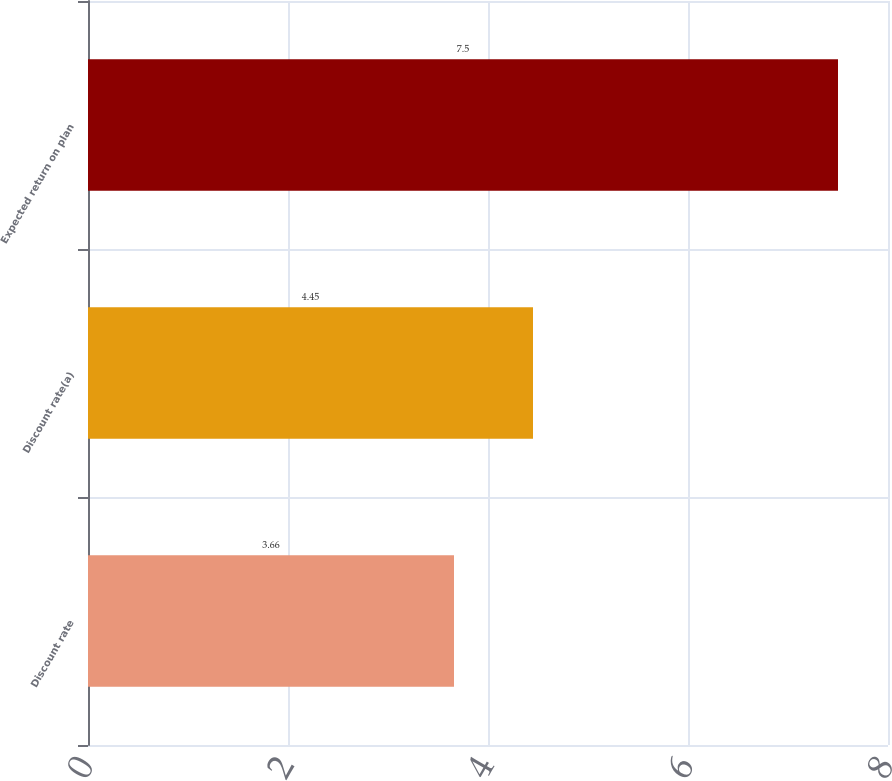Convert chart to OTSL. <chart><loc_0><loc_0><loc_500><loc_500><bar_chart><fcel>Discount rate<fcel>Discount rate(a)<fcel>Expected return on plan<nl><fcel>3.66<fcel>4.45<fcel>7.5<nl></chart> 